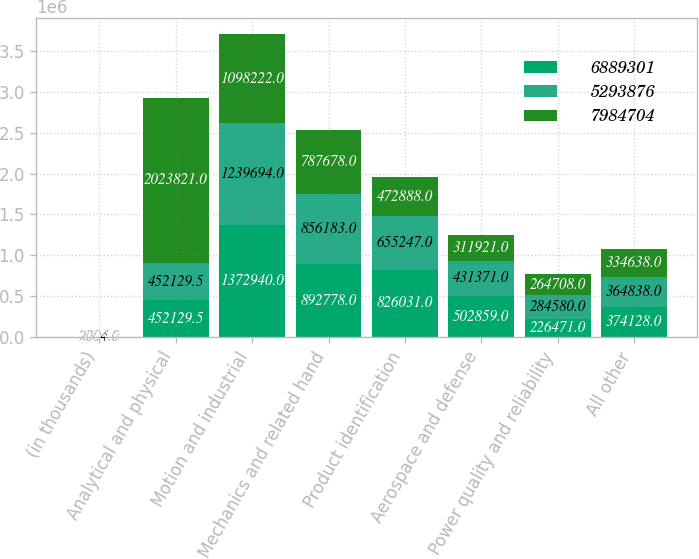Convert chart. <chart><loc_0><loc_0><loc_500><loc_500><stacked_bar_chart><ecel><fcel>(in thousands)<fcel>Analytical and physical<fcel>Motion and industrial<fcel>Mechanics and related hand<fcel>Product identification<fcel>Aerospace and defense<fcel>Power quality and reliability<fcel>All other<nl><fcel>6.8893e+06<fcel>2005<fcel>452130<fcel>1.37294e+06<fcel>892778<fcel>826031<fcel>502859<fcel>226471<fcel>374128<nl><fcel>5.29388e+06<fcel>2004<fcel>452130<fcel>1.23969e+06<fcel>856183<fcel>655247<fcel>431371<fcel>284580<fcel>364838<nl><fcel>7.9847e+06<fcel>2003<fcel>2.02382e+06<fcel>1.09822e+06<fcel>787678<fcel>472888<fcel>311921<fcel>264708<fcel>334638<nl></chart> 